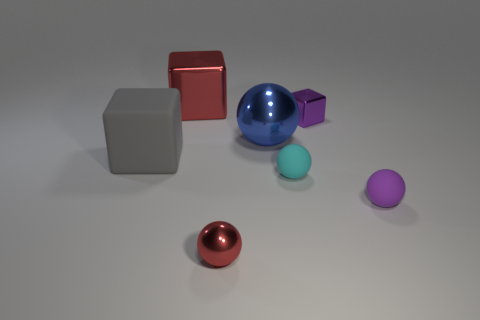Are there any tiny yellow blocks?
Offer a terse response. No. Does the small shiny ball have the same color as the big cube behind the gray matte block?
Keep it short and to the point. Yes. What color is the small block?
Your answer should be very brief. Purple. There is a tiny shiny thing that is the same shape as the large blue object; what is its color?
Your response must be concise. Red. Do the big matte object and the purple rubber thing have the same shape?
Offer a very short reply. No. How many cylinders are tiny purple metallic objects or red metal things?
Offer a terse response. 0. There is a large object that is made of the same material as the cyan sphere; what is its color?
Your answer should be compact. Gray. There is a rubber thing that is behind the cyan matte object; is its size the same as the big blue metal object?
Offer a terse response. Yes. Do the small purple cube and the small purple thing that is in front of the small cyan rubber object have the same material?
Offer a very short reply. No. What color is the large thing in front of the large sphere?
Provide a short and direct response. Gray. 